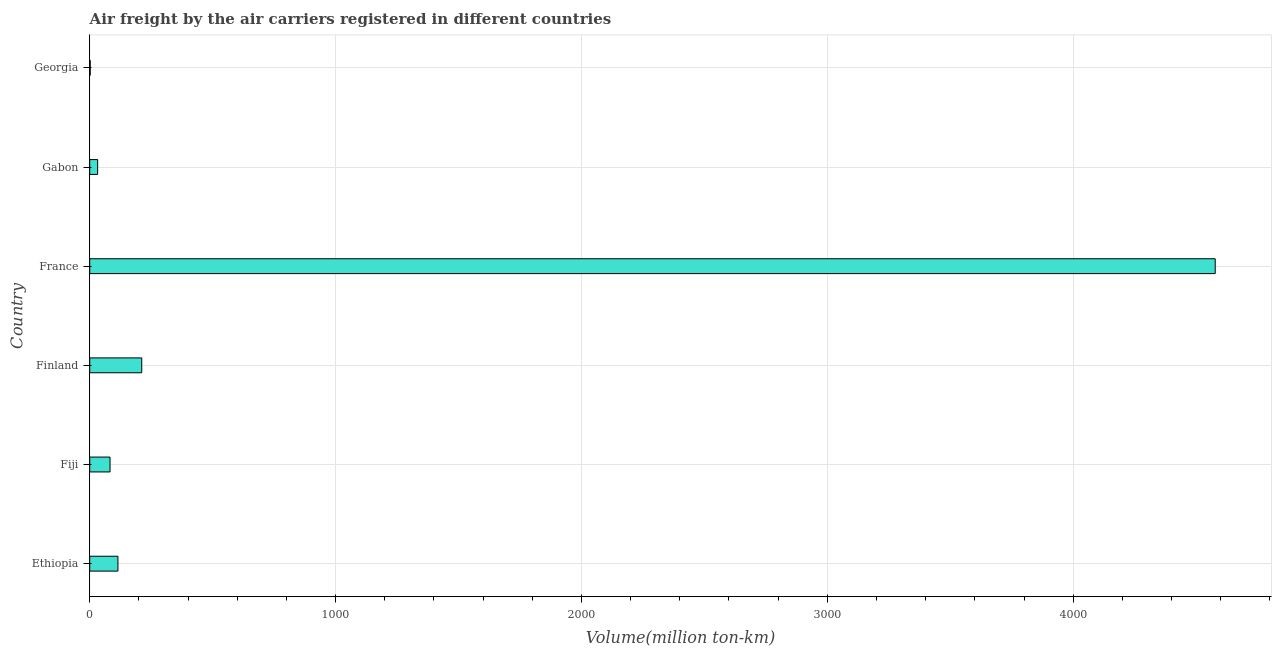Does the graph contain any zero values?
Ensure brevity in your answer.  No. What is the title of the graph?
Your response must be concise. Air freight by the air carriers registered in different countries. What is the label or title of the X-axis?
Ensure brevity in your answer.  Volume(million ton-km). What is the air freight in Georgia?
Your response must be concise. 1.9. Across all countries, what is the maximum air freight?
Give a very brief answer. 4577.7. Across all countries, what is the minimum air freight?
Your answer should be very brief. 1.9. In which country was the air freight maximum?
Ensure brevity in your answer.  France. In which country was the air freight minimum?
Give a very brief answer. Georgia. What is the sum of the air freight?
Keep it short and to the point. 5020.6. What is the difference between the air freight in France and Georgia?
Ensure brevity in your answer.  4575.8. What is the average air freight per country?
Your response must be concise. 836.77. What is the median air freight?
Ensure brevity in your answer.  98.65. In how many countries, is the air freight greater than 3600 million ton-km?
Ensure brevity in your answer.  1. What is the ratio of the air freight in Ethiopia to that in Georgia?
Provide a succinct answer. 60.37. Is the air freight in Gabon less than that in Georgia?
Ensure brevity in your answer.  No. What is the difference between the highest and the second highest air freight?
Make the answer very short. 4366.2. What is the difference between the highest and the lowest air freight?
Your response must be concise. 4575.8. In how many countries, is the air freight greater than the average air freight taken over all countries?
Give a very brief answer. 1. How many countries are there in the graph?
Make the answer very short. 6. What is the difference between two consecutive major ticks on the X-axis?
Make the answer very short. 1000. What is the Volume(million ton-km) in Ethiopia?
Provide a succinct answer. 114.7. What is the Volume(million ton-km) of Fiji?
Offer a very short reply. 82.6. What is the Volume(million ton-km) of Finland?
Your answer should be very brief. 211.5. What is the Volume(million ton-km) of France?
Offer a terse response. 4577.7. What is the Volume(million ton-km) of Gabon?
Keep it short and to the point. 32.2. What is the Volume(million ton-km) in Georgia?
Provide a succinct answer. 1.9. What is the difference between the Volume(million ton-km) in Ethiopia and Fiji?
Provide a succinct answer. 32.1. What is the difference between the Volume(million ton-km) in Ethiopia and Finland?
Offer a terse response. -96.8. What is the difference between the Volume(million ton-km) in Ethiopia and France?
Provide a short and direct response. -4463. What is the difference between the Volume(million ton-km) in Ethiopia and Gabon?
Offer a very short reply. 82.5. What is the difference between the Volume(million ton-km) in Ethiopia and Georgia?
Keep it short and to the point. 112.8. What is the difference between the Volume(million ton-km) in Fiji and Finland?
Your answer should be compact. -128.9. What is the difference between the Volume(million ton-km) in Fiji and France?
Keep it short and to the point. -4495.1. What is the difference between the Volume(million ton-km) in Fiji and Gabon?
Give a very brief answer. 50.4. What is the difference between the Volume(million ton-km) in Fiji and Georgia?
Give a very brief answer. 80.7. What is the difference between the Volume(million ton-km) in Finland and France?
Your response must be concise. -4366.2. What is the difference between the Volume(million ton-km) in Finland and Gabon?
Your response must be concise. 179.3. What is the difference between the Volume(million ton-km) in Finland and Georgia?
Your response must be concise. 209.6. What is the difference between the Volume(million ton-km) in France and Gabon?
Ensure brevity in your answer.  4545.5. What is the difference between the Volume(million ton-km) in France and Georgia?
Offer a very short reply. 4575.8. What is the difference between the Volume(million ton-km) in Gabon and Georgia?
Offer a very short reply. 30.3. What is the ratio of the Volume(million ton-km) in Ethiopia to that in Fiji?
Your answer should be very brief. 1.39. What is the ratio of the Volume(million ton-km) in Ethiopia to that in Finland?
Ensure brevity in your answer.  0.54. What is the ratio of the Volume(million ton-km) in Ethiopia to that in France?
Offer a terse response. 0.03. What is the ratio of the Volume(million ton-km) in Ethiopia to that in Gabon?
Your answer should be very brief. 3.56. What is the ratio of the Volume(million ton-km) in Ethiopia to that in Georgia?
Offer a very short reply. 60.37. What is the ratio of the Volume(million ton-km) in Fiji to that in Finland?
Provide a succinct answer. 0.39. What is the ratio of the Volume(million ton-km) in Fiji to that in France?
Provide a succinct answer. 0.02. What is the ratio of the Volume(million ton-km) in Fiji to that in Gabon?
Keep it short and to the point. 2.56. What is the ratio of the Volume(million ton-km) in Fiji to that in Georgia?
Your response must be concise. 43.47. What is the ratio of the Volume(million ton-km) in Finland to that in France?
Keep it short and to the point. 0.05. What is the ratio of the Volume(million ton-km) in Finland to that in Gabon?
Your answer should be compact. 6.57. What is the ratio of the Volume(million ton-km) in Finland to that in Georgia?
Offer a terse response. 111.32. What is the ratio of the Volume(million ton-km) in France to that in Gabon?
Provide a short and direct response. 142.16. What is the ratio of the Volume(million ton-km) in France to that in Georgia?
Ensure brevity in your answer.  2409.32. What is the ratio of the Volume(million ton-km) in Gabon to that in Georgia?
Ensure brevity in your answer.  16.95. 